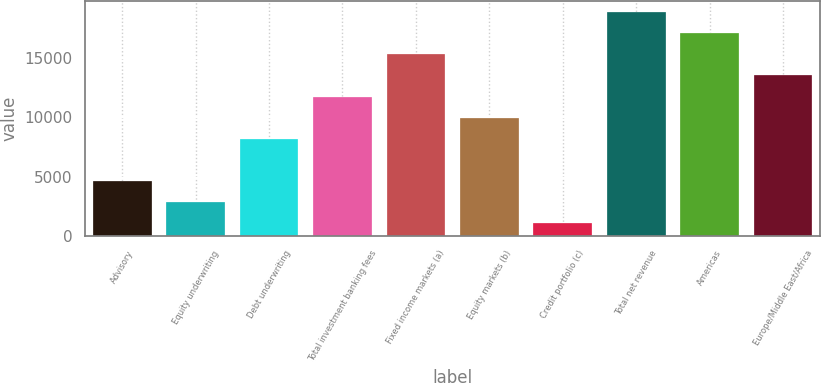<chart> <loc_0><loc_0><loc_500><loc_500><bar_chart><fcel>Advisory<fcel>Equity underwriting<fcel>Debt underwriting<fcel>Total investment banking fees<fcel>Fixed income markets (a)<fcel>Equity markets (b)<fcel>Credit portfolio (c)<fcel>Total net revenue<fcel>Americas<fcel>Europe/Middle East/Africa<nl><fcel>4648.2<fcel>2875.1<fcel>8194.4<fcel>11740.6<fcel>15286.8<fcel>9967.5<fcel>1102<fcel>18833<fcel>17059.9<fcel>13513.7<nl></chart> 